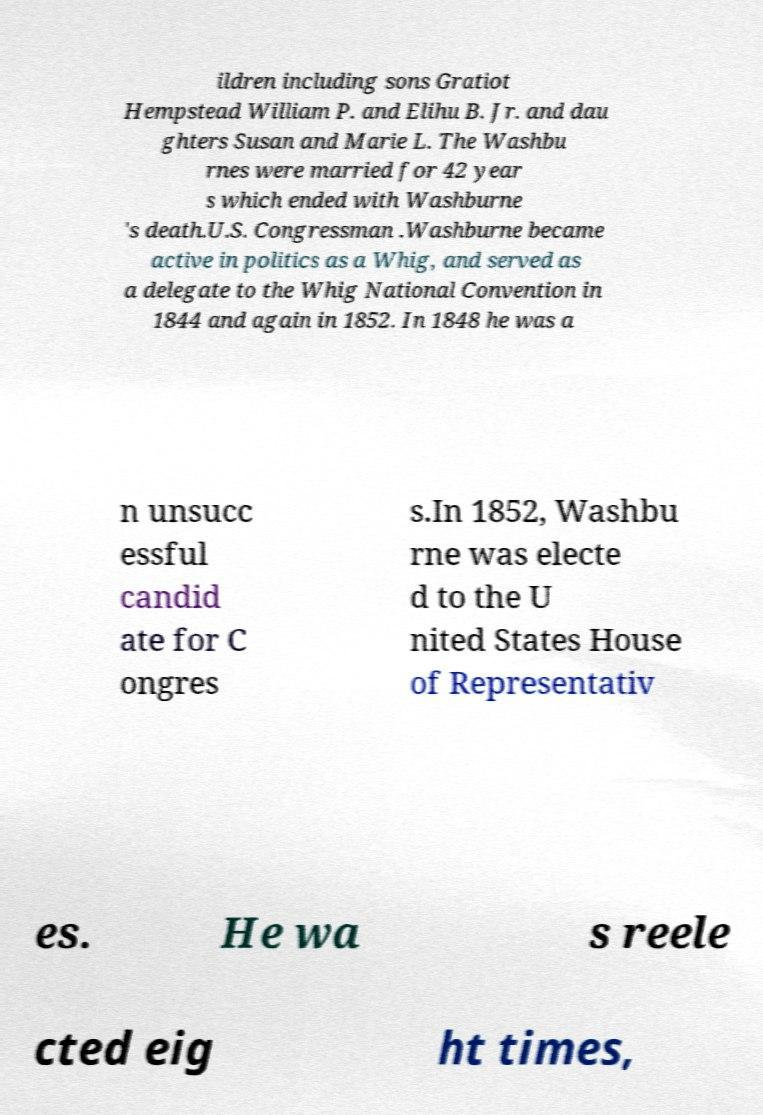What messages or text are displayed in this image? I need them in a readable, typed format. ildren including sons Gratiot Hempstead William P. and Elihu B. Jr. and dau ghters Susan and Marie L. The Washbu rnes were married for 42 year s which ended with Washburne 's death.U.S. Congressman .Washburne became active in politics as a Whig, and served as a delegate to the Whig National Convention in 1844 and again in 1852. In 1848 he was a n unsucc essful candid ate for C ongres s.In 1852, Washbu rne was electe d to the U nited States House of Representativ es. He wa s reele cted eig ht times, 